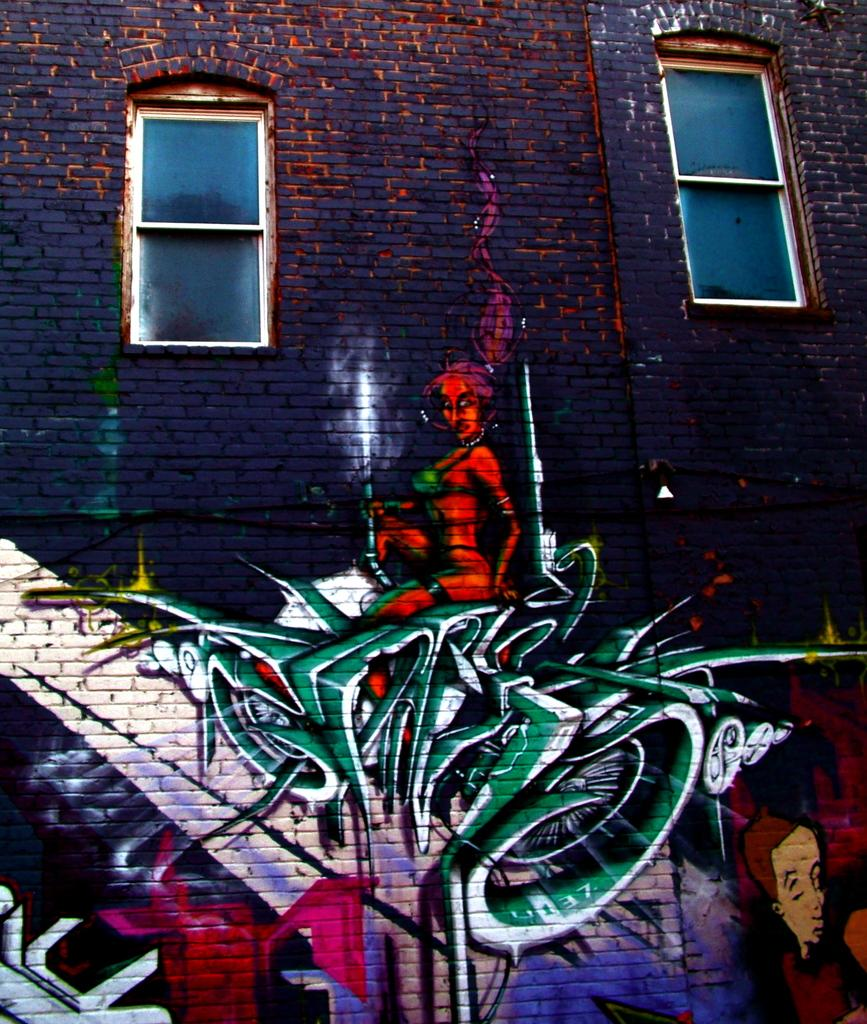What type of structure is visible in the image? There is a building in the image. How many windows can be seen on the building? There are two windows on the building. What is present on the building's exterior? There is graffiti on the building. What type of agreement was reached between the two parties in the image? There is no indication of any agreement or parties in the image; it only features a building with graffiti and windows. 